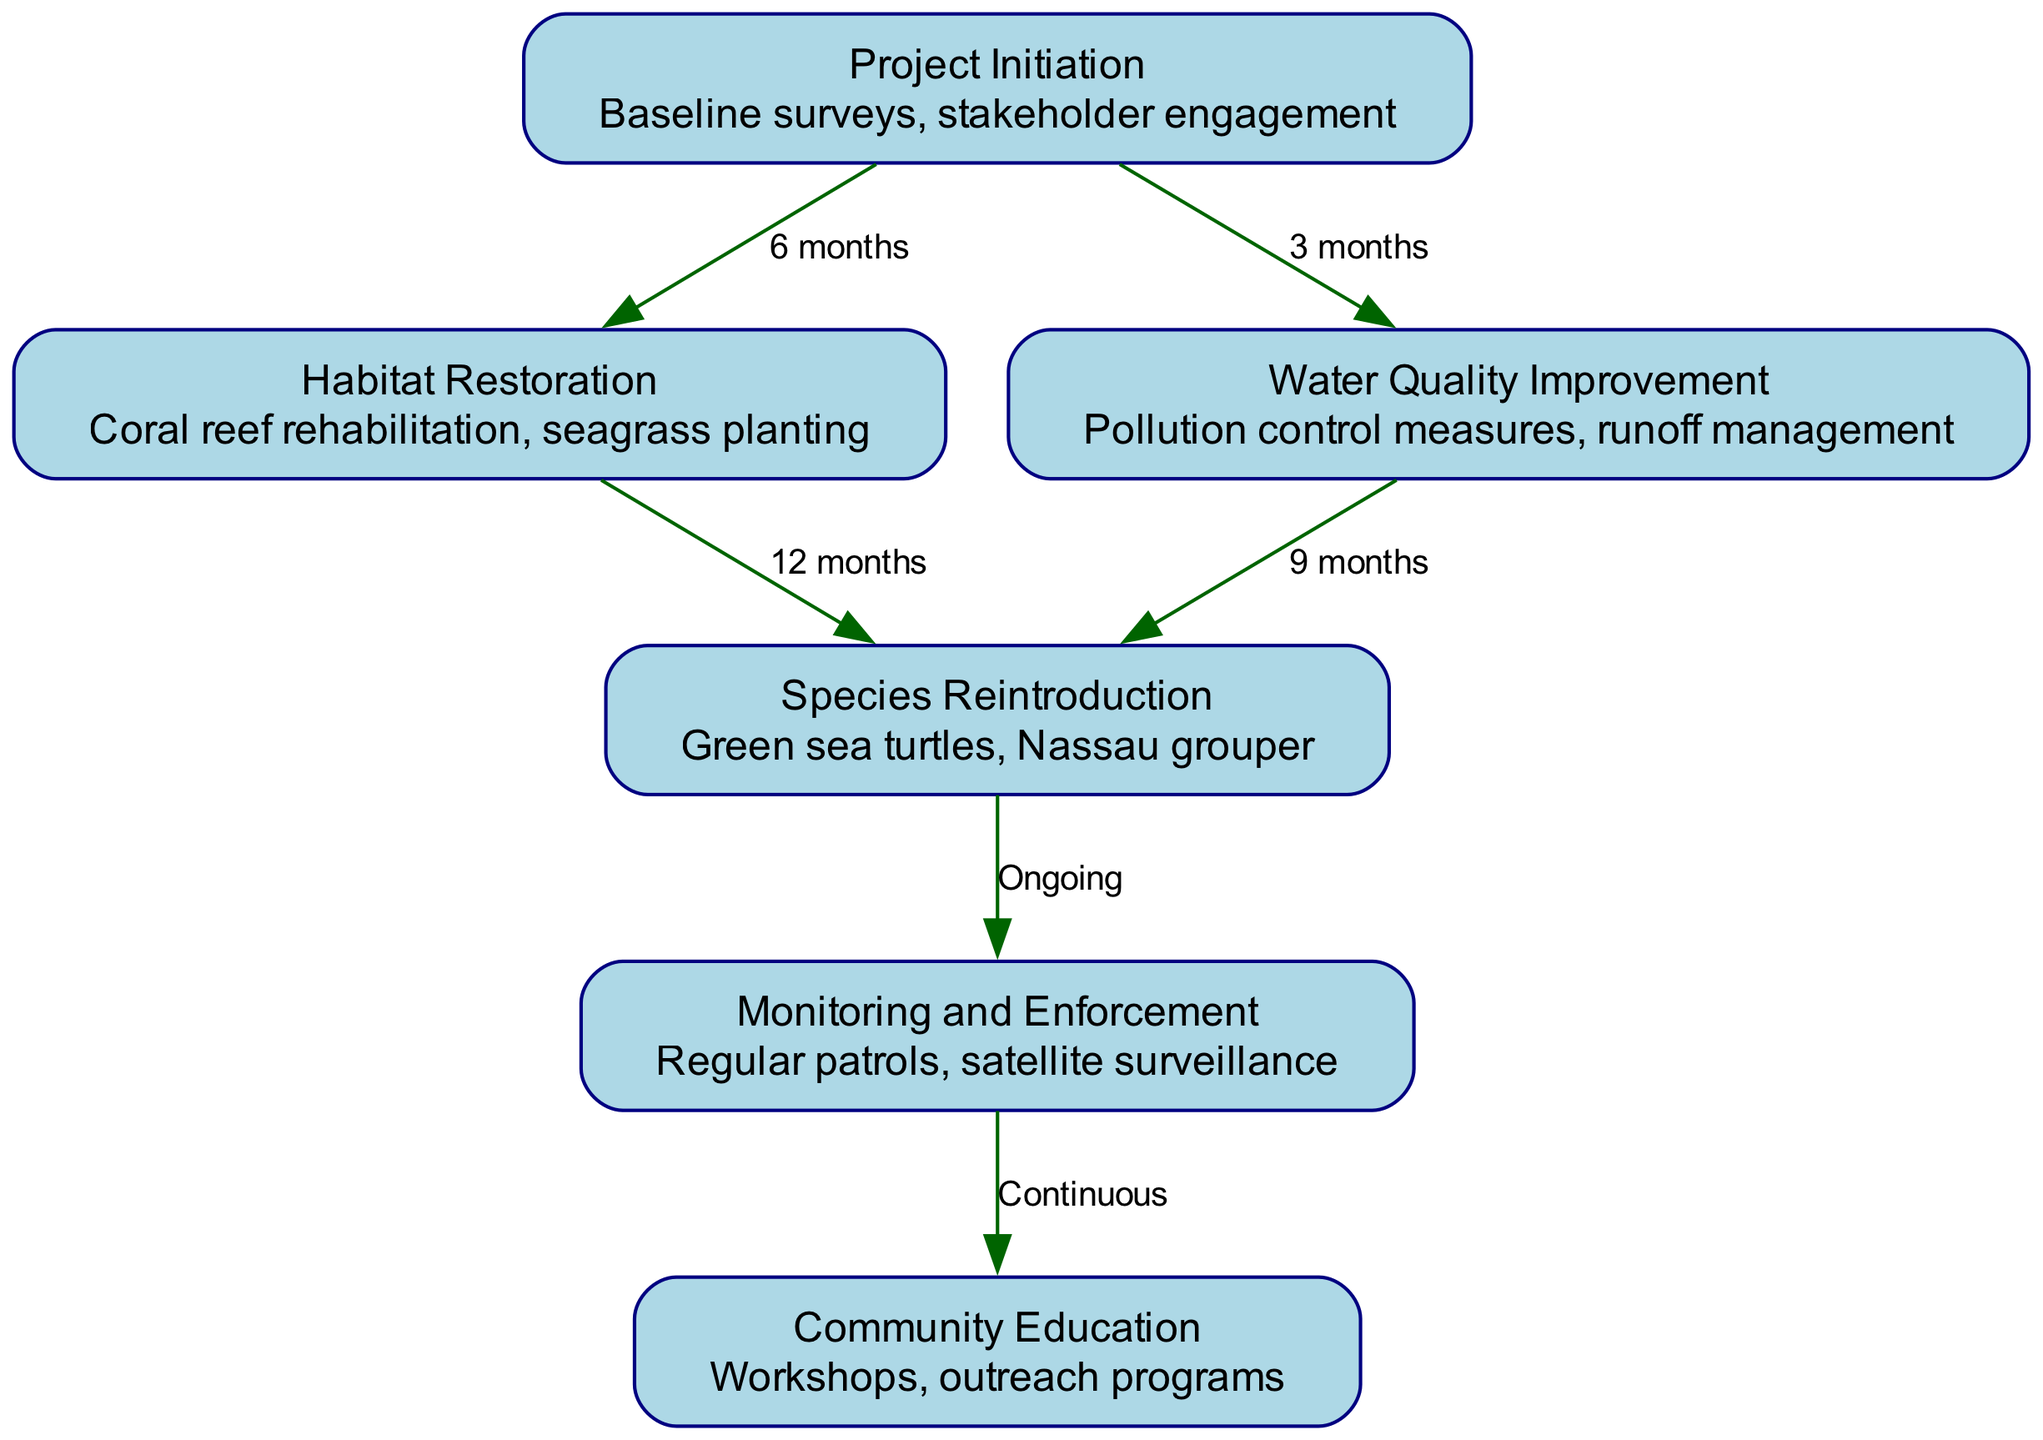What is the first step in the project? The first step is indicated by the node labeled "Project Initiation". This node outlines the processes of baseline surveys and stakeholder engagement that begin the project.
Answer: Project Initiation How many months does Habitat Restoration take? The edge connecting "Project Initiation" to "Habitat Restoration" is labeled as "6 months", indicating the duration required for this step.
Answer: 6 months What species are being reintroduced? The node labeled "Species Reintroduction" specifies the species to be reintroduced, which are green sea turtles and Nassau grouper.
Answer: Green sea turtles, Nassau grouper What follows after Species Reintroduction? The edge from "Species Reintroduction" to "Monitoring and Enforcement" shows that this step follows immediately after. The label "Ongoing" indicates that this phase is continuous.
Answer: Monitoring and Enforcement What is the duration between Water Quality Improvement and Species Reintroduction? The edge shows that Water Quality Improvement must be completed before Species Reintroduction can begin, taking 9 months. Therefore, this time reflects the gap between these two steps.
Answer: 9 months Which nodes are connected by the longest duration in the diagram? The edges reveal that the longest duration occurs between "Habitat Restoration" and "Species Reintroduction", with a total time span of 12 months. This indicates that habitat restoration is critical before reintroducing species.
Answer: 12 months How does Community Education relate to the enforcement of the project? The diagram indicates that "Monitoring and Enforcement" leads to "Community Education", and the label "Continuous" suggests ongoing efforts in education as part of enforcement measures.
Answer: Continuous What is the total number of nodes in the diagram? By counting all uniquely labeled steps, there are six nodes: Project Initiation, Habitat Restoration, Water Quality Improvement, Species Reintroduction, Monitoring and Enforcement, Community Education.
Answer: 6 Which phase addresses pollution control measures? The node "Water Quality Improvement" is specifically responsible for pollution control measures, along with runoff management, according to its details provided in the diagram.
Answer: Water Quality Improvement 